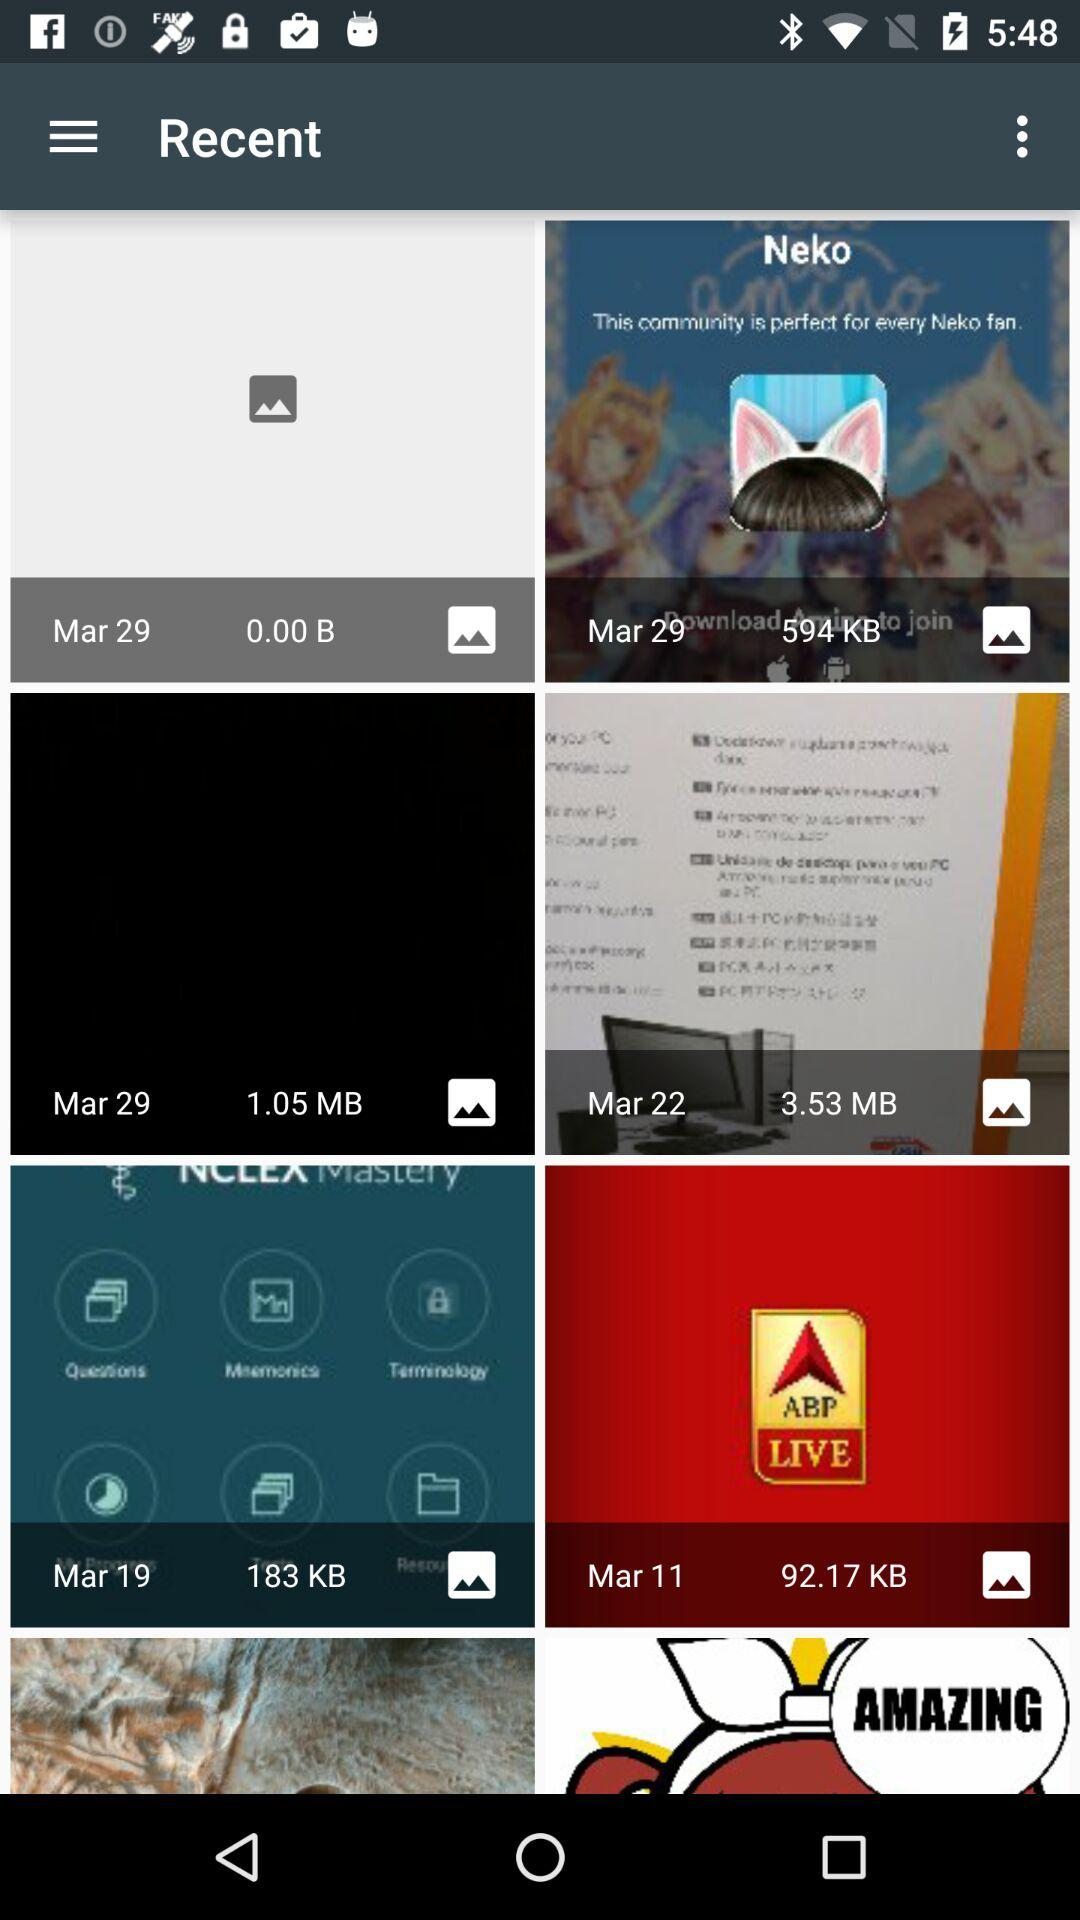What is the size of the image taken on March 22? The size of the image taken on March 22 is 3.53 MB. 